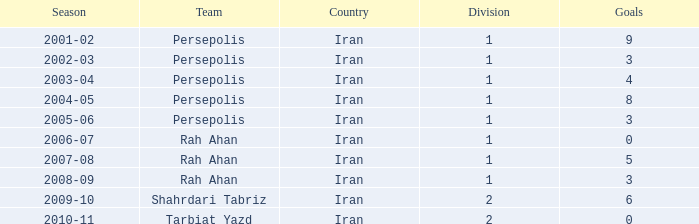What is the average Goals, when Team is "Rah Ahan", and when Division is less than 1? None. 